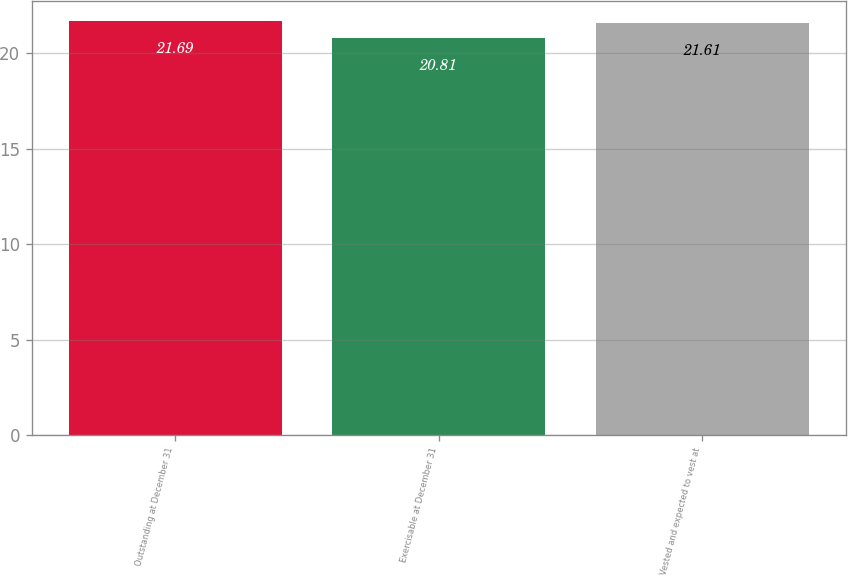<chart> <loc_0><loc_0><loc_500><loc_500><bar_chart><fcel>Outstanding at December 31<fcel>Exercisable at December 31<fcel>Vested and expected to vest at<nl><fcel>21.69<fcel>20.81<fcel>21.61<nl></chart> 